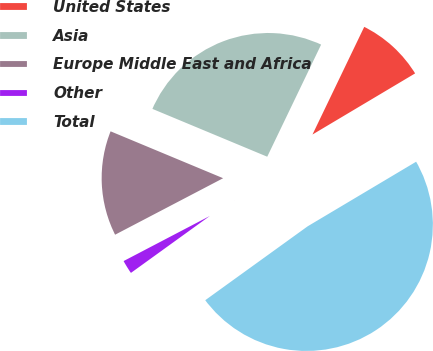Convert chart to OTSL. <chart><loc_0><loc_0><loc_500><loc_500><pie_chart><fcel>United States<fcel>Asia<fcel>Europe Middle East and Africa<fcel>Other<fcel>Total<nl><fcel>9.32%<fcel>25.85%<fcel>13.95%<fcel>2.28%<fcel>48.6%<nl></chart> 